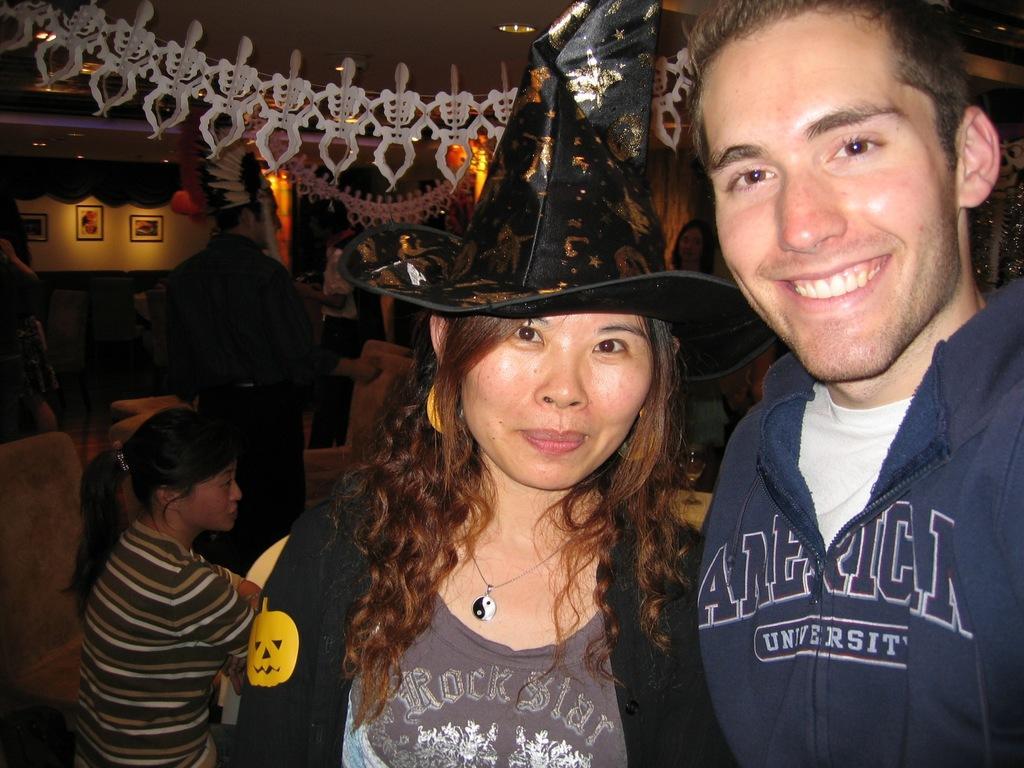Can you describe this image briefly? In this picture I can observe a couple. Both of them are smiling. Woman is wearing black color hat on her head. In the background I can observe some people. On the left side there are some photo frames on the wall. 